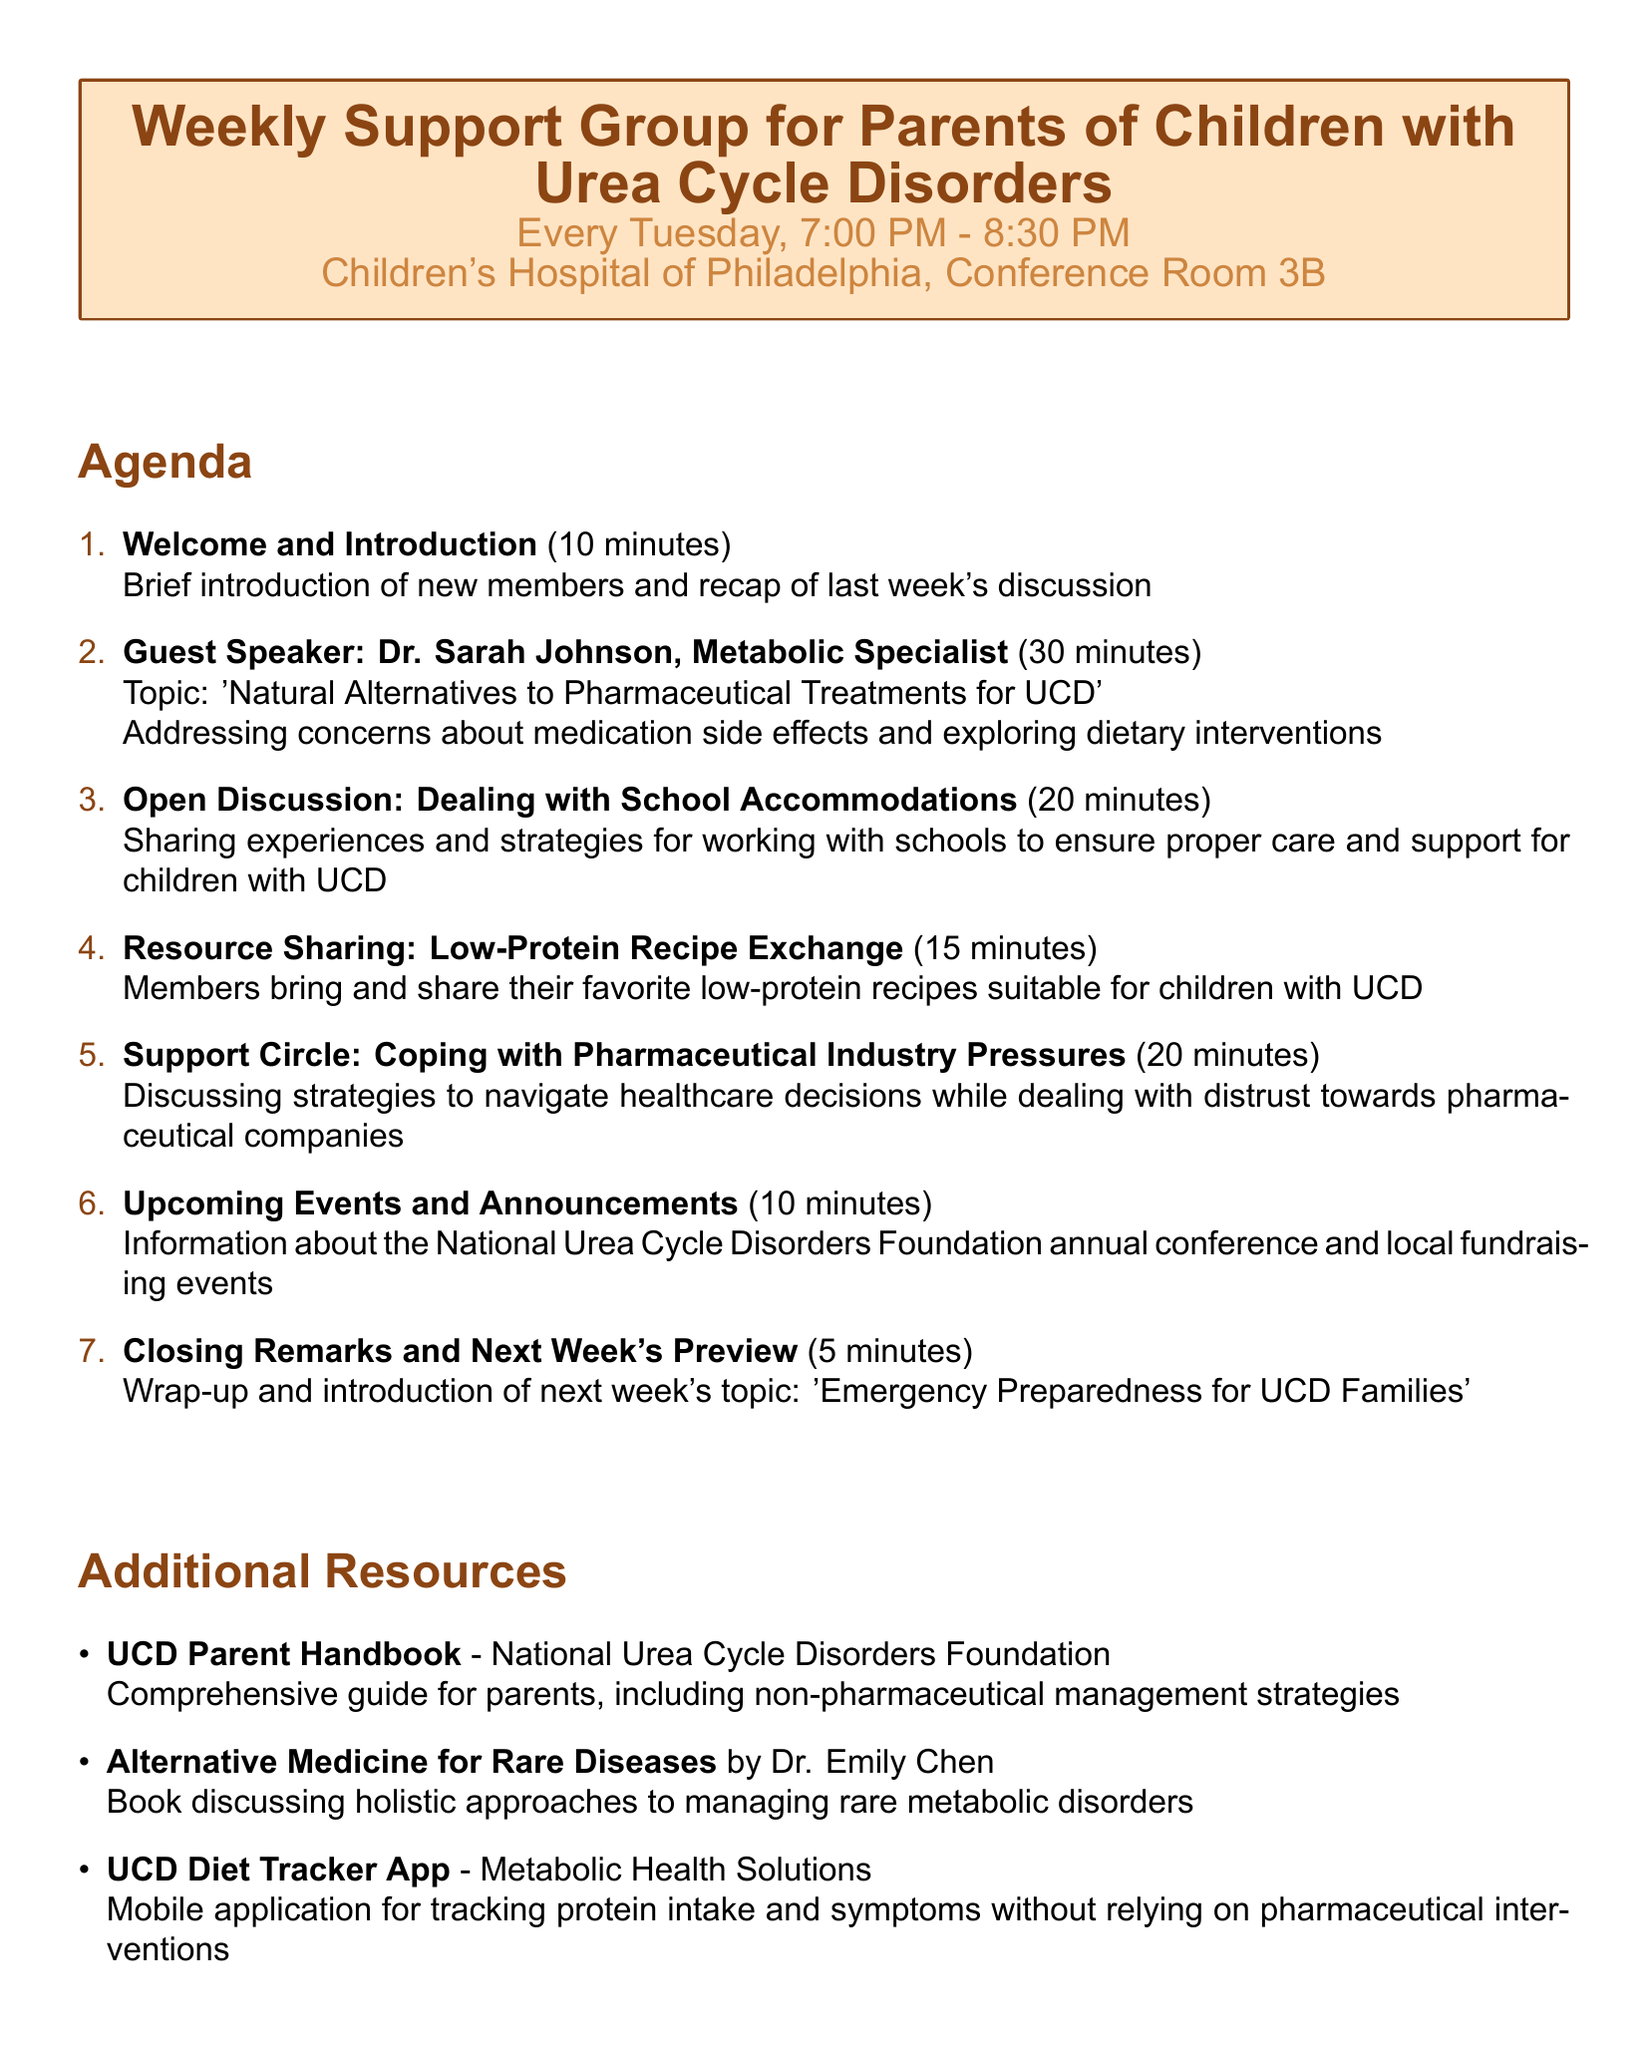What day of the week are the meetings held? The meetings are scheduled every Tuesday, as mentioned in the document.
Answer: Tuesday Who is the guest speaker for this meeting? The agenda lists Dr. Sarah Johnson as the guest speaker.
Answer: Dr. Sarah Johnson What is the duration of the Open Discussion segment? The document specifies that the Open Discussion lasts for 20 minutes.
Answer: 20 minutes What is the main topic of discussion in the Support Circle? The Support Circle focuses on coping with pressures from pharmaceutical companies, as outlined in the agenda.
Answer: Coping with Pharmaceutical Industry Pressures How long is allocated for the Welcome and Introduction? According to the agenda, 10 minutes is designated for the Welcome and Introduction.
Answer: 10 minutes What upcoming topic will be previewed in the closing remarks? The agenda notes that next week's topic will be "Emergency Preparedness for UCD Families."
Answer: Emergency Preparedness for UCD Families How many minutes are dedicated to the Resource Sharing segment? The document states that 15 minutes are allocated to the Resource Sharing segment.
Answer: 15 minutes What is provided by the UCD Family Counseling support service? The document outlines that it offers counseling specialized for families dealing with rare metabolic disorders.
Answer: Licensed therapist specializing in families dealing with rare metabolic disorders What is the purpose of the Low-Protein Recipe Exchange? The agenda details this exchange for members to share their favorite low-protein recipes for children with UCD.
Answer: Sharing low-protein recipes 